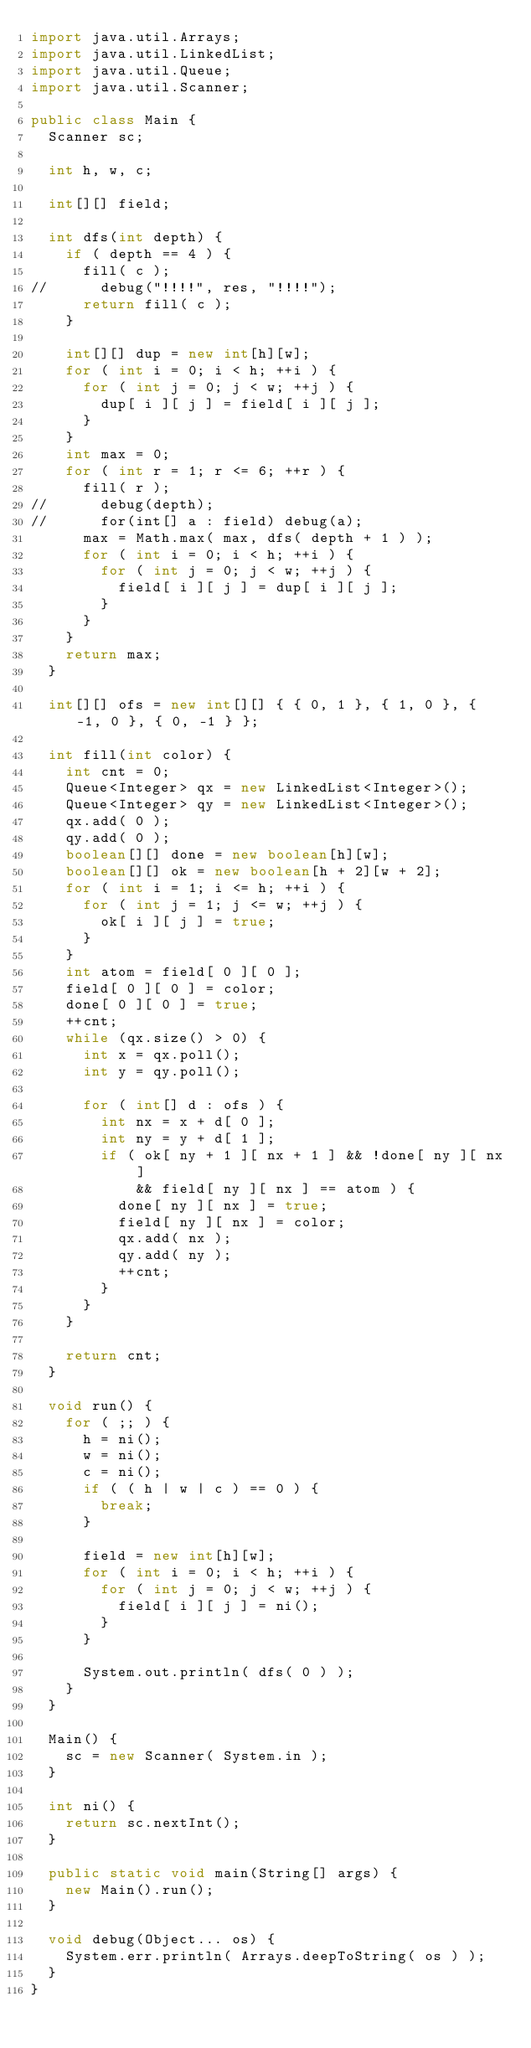<code> <loc_0><loc_0><loc_500><loc_500><_Java_>import java.util.Arrays;
import java.util.LinkedList;
import java.util.Queue;
import java.util.Scanner;

public class Main {
  Scanner sc;

  int h, w, c;

  int[][] field;

  int dfs(int depth) {
    if ( depth == 4 ) {
      fill( c );
//      debug("!!!!", res, "!!!!");
      return fill( c );
    }

    int[][] dup = new int[h][w];
    for ( int i = 0; i < h; ++i ) {
      for ( int j = 0; j < w; ++j ) {
        dup[ i ][ j ] = field[ i ][ j ];
      }
    }
    int max = 0;
    for ( int r = 1; r <= 6; ++r ) {
      fill( r );
//      debug(depth);
//      for(int[] a : field) debug(a);
      max = Math.max( max, dfs( depth + 1 ) );
      for ( int i = 0; i < h; ++i ) {
        for ( int j = 0; j < w; ++j ) {
          field[ i ][ j ] = dup[ i ][ j ];
        }
      }
    }
    return max;
  }

  int[][] ofs = new int[][] { { 0, 1 }, { 1, 0 }, { -1, 0 }, { 0, -1 } };

  int fill(int color) {
    int cnt = 0;
    Queue<Integer> qx = new LinkedList<Integer>();
    Queue<Integer> qy = new LinkedList<Integer>();
    qx.add( 0 );
    qy.add( 0 );
    boolean[][] done = new boolean[h][w];
    boolean[][] ok = new boolean[h + 2][w + 2];
    for ( int i = 1; i <= h; ++i ) {
      for ( int j = 1; j <= w; ++j ) {
        ok[ i ][ j ] = true;
      }
    }
    int atom = field[ 0 ][ 0 ];
    field[ 0 ][ 0 ] = color;
    done[ 0 ][ 0 ] = true;
    ++cnt;
    while (qx.size() > 0) {
      int x = qx.poll();
      int y = qy.poll();

      for ( int[] d : ofs ) {
        int nx = x + d[ 0 ];
        int ny = y + d[ 1 ];
        if ( ok[ ny + 1 ][ nx + 1 ] && !done[ ny ][ nx ]
            && field[ ny ][ nx ] == atom ) {
          done[ ny ][ nx ] = true;
          field[ ny ][ nx ] = color;
          qx.add( nx );
          qy.add( ny );
          ++cnt;
        }
      }
    }

    return cnt;
  }

  void run() {
    for ( ;; ) {
      h = ni();
      w = ni();
      c = ni();
      if ( ( h | w | c ) == 0 ) {
        break;
      }

      field = new int[h][w];
      for ( int i = 0; i < h; ++i ) {
        for ( int j = 0; j < w; ++j ) {
          field[ i ][ j ] = ni();
        }
      }

      System.out.println( dfs( 0 ) );
    }
  }

  Main() {
    sc = new Scanner( System.in );
  }

  int ni() {
    return sc.nextInt();
  }

  public static void main(String[] args) {
    new Main().run();
  }

  void debug(Object... os) {
    System.err.println( Arrays.deepToString( os ) );
  }
}</code> 